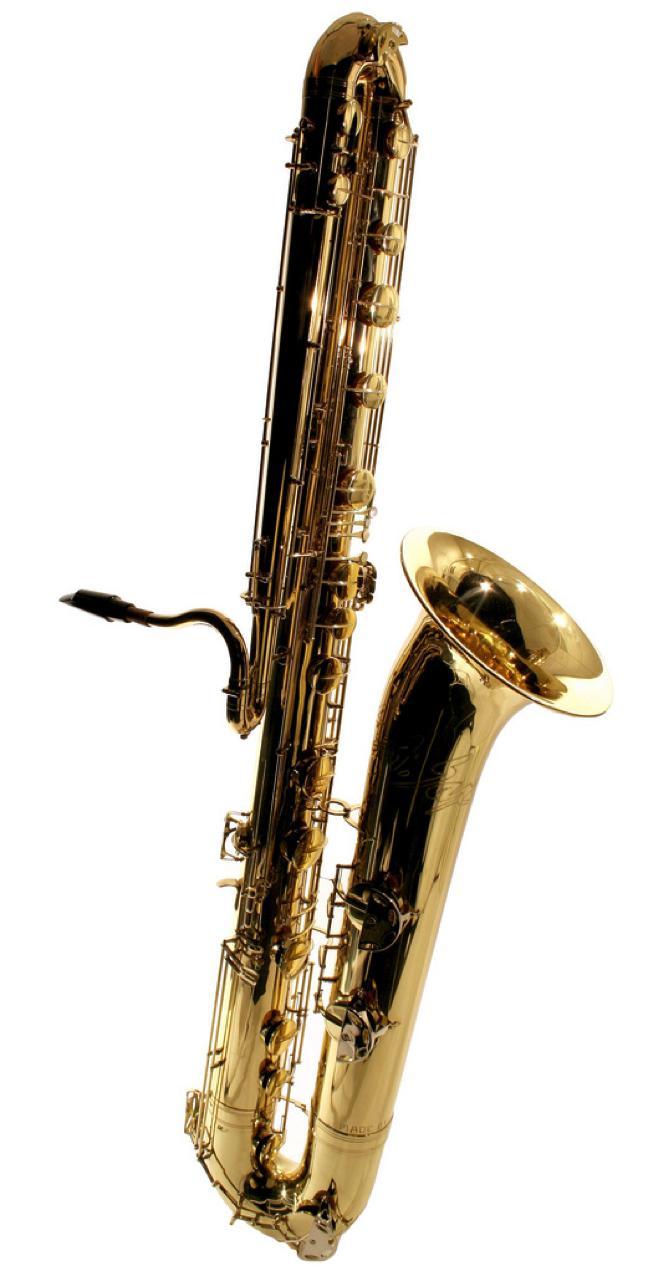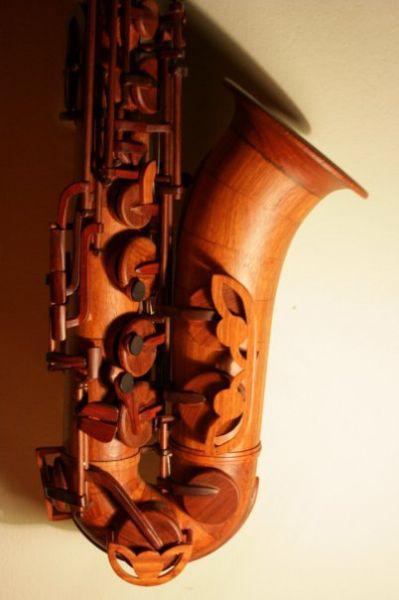The first image is the image on the left, the second image is the image on the right. For the images shown, is this caption "The saxophone in the image on the left is against a solid white background." true? Answer yes or no. Yes. 